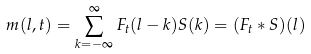<formula> <loc_0><loc_0><loc_500><loc_500>m ( l , t ) = \sum _ { k = - \infty } ^ { \infty } F _ { t } ( l - k ) S ( k ) = ( F _ { t } * S ) ( l )</formula> 